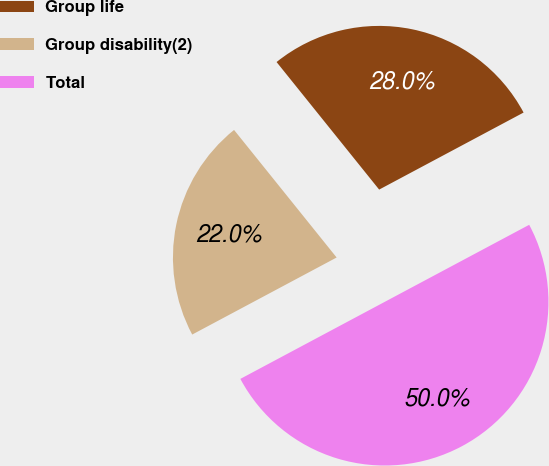<chart> <loc_0><loc_0><loc_500><loc_500><pie_chart><fcel>Group life<fcel>Group disability(2)<fcel>Total<nl><fcel>27.98%<fcel>22.02%<fcel>50.0%<nl></chart> 